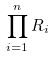<formula> <loc_0><loc_0><loc_500><loc_500>\prod _ { i = 1 } ^ { n } R _ { i }</formula> 